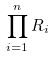<formula> <loc_0><loc_0><loc_500><loc_500>\prod _ { i = 1 } ^ { n } R _ { i }</formula> 